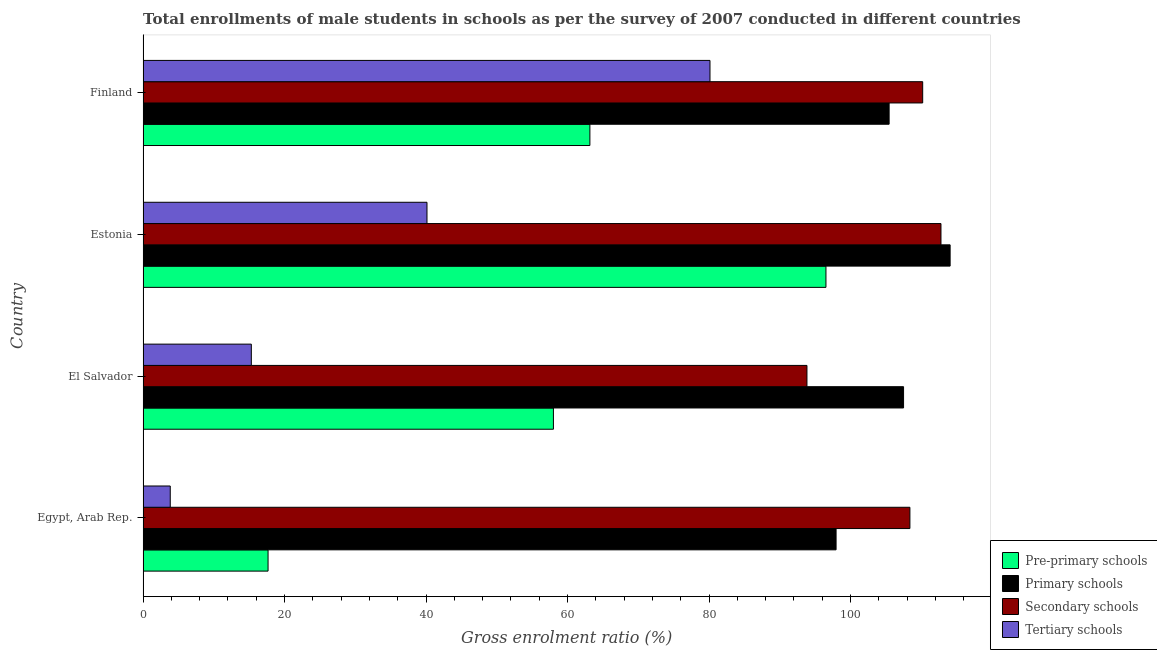Are the number of bars per tick equal to the number of legend labels?
Provide a succinct answer. Yes. How many bars are there on the 3rd tick from the top?
Give a very brief answer. 4. What is the label of the 1st group of bars from the top?
Give a very brief answer. Finland. In how many cases, is the number of bars for a given country not equal to the number of legend labels?
Keep it short and to the point. 0. What is the gross enrolment ratio(male) in pre-primary schools in Egypt, Arab Rep.?
Offer a terse response. 17.67. Across all countries, what is the maximum gross enrolment ratio(male) in pre-primary schools?
Offer a very short reply. 96.53. Across all countries, what is the minimum gross enrolment ratio(male) in pre-primary schools?
Your answer should be very brief. 17.67. In which country was the gross enrolment ratio(male) in primary schools minimum?
Offer a very short reply. Egypt, Arab Rep. What is the total gross enrolment ratio(male) in tertiary schools in the graph?
Offer a terse response. 139.42. What is the difference between the gross enrolment ratio(male) in pre-primary schools in Estonia and that in Finland?
Offer a very short reply. 33.37. What is the difference between the gross enrolment ratio(male) in tertiary schools in Egypt, Arab Rep. and the gross enrolment ratio(male) in secondary schools in El Salvador?
Give a very brief answer. -90. What is the average gross enrolment ratio(male) in secondary schools per country?
Keep it short and to the point. 106.31. What is the difference between the gross enrolment ratio(male) in pre-primary schools and gross enrolment ratio(male) in primary schools in Estonia?
Offer a very short reply. -17.55. In how many countries, is the gross enrolment ratio(male) in tertiary schools greater than 44 %?
Offer a terse response. 1. What is the ratio of the gross enrolment ratio(male) in tertiary schools in El Salvador to that in Finland?
Provide a short and direct response. 0.19. Is the difference between the gross enrolment ratio(male) in tertiary schools in Egypt, Arab Rep. and El Salvador greater than the difference between the gross enrolment ratio(male) in primary schools in Egypt, Arab Rep. and El Salvador?
Your answer should be very brief. No. What is the difference between the highest and the second highest gross enrolment ratio(male) in tertiary schools?
Your response must be concise. 40.01. What is the difference between the highest and the lowest gross enrolment ratio(male) in primary schools?
Give a very brief answer. 16.12. Is it the case that in every country, the sum of the gross enrolment ratio(male) in pre-primary schools and gross enrolment ratio(male) in primary schools is greater than the sum of gross enrolment ratio(male) in tertiary schools and gross enrolment ratio(male) in secondary schools?
Your answer should be compact. No. What does the 1st bar from the top in Estonia represents?
Your answer should be compact. Tertiary schools. What does the 3rd bar from the bottom in Finland represents?
Your response must be concise. Secondary schools. How many bars are there?
Provide a succinct answer. 16. Are all the bars in the graph horizontal?
Make the answer very short. Yes. How many countries are there in the graph?
Keep it short and to the point. 4. How many legend labels are there?
Keep it short and to the point. 4. How are the legend labels stacked?
Give a very brief answer. Vertical. What is the title of the graph?
Give a very brief answer. Total enrollments of male students in schools as per the survey of 2007 conducted in different countries. What is the label or title of the X-axis?
Provide a succinct answer. Gross enrolment ratio (%). What is the label or title of the Y-axis?
Your answer should be compact. Country. What is the Gross enrolment ratio (%) in Pre-primary schools in Egypt, Arab Rep.?
Provide a succinct answer. 17.67. What is the Gross enrolment ratio (%) of Primary schools in Egypt, Arab Rep.?
Offer a very short reply. 97.97. What is the Gross enrolment ratio (%) of Secondary schools in Egypt, Arab Rep.?
Ensure brevity in your answer.  108.4. What is the Gross enrolment ratio (%) of Tertiary schools in Egypt, Arab Rep.?
Ensure brevity in your answer.  3.84. What is the Gross enrolment ratio (%) of Pre-primary schools in El Salvador?
Your response must be concise. 58.01. What is the Gross enrolment ratio (%) of Primary schools in El Salvador?
Your answer should be compact. 107.5. What is the Gross enrolment ratio (%) of Secondary schools in El Salvador?
Offer a terse response. 93.85. What is the Gross enrolment ratio (%) of Tertiary schools in El Salvador?
Your answer should be very brief. 15.31. What is the Gross enrolment ratio (%) in Pre-primary schools in Estonia?
Provide a succinct answer. 96.53. What is the Gross enrolment ratio (%) of Primary schools in Estonia?
Your answer should be compact. 114.09. What is the Gross enrolment ratio (%) of Secondary schools in Estonia?
Offer a terse response. 112.79. What is the Gross enrolment ratio (%) in Tertiary schools in Estonia?
Offer a very short reply. 40.13. What is the Gross enrolment ratio (%) of Pre-primary schools in Finland?
Provide a succinct answer. 63.16. What is the Gross enrolment ratio (%) of Primary schools in Finland?
Give a very brief answer. 105.46. What is the Gross enrolment ratio (%) in Secondary schools in Finland?
Provide a succinct answer. 110.21. What is the Gross enrolment ratio (%) of Tertiary schools in Finland?
Provide a short and direct response. 80.14. Across all countries, what is the maximum Gross enrolment ratio (%) of Pre-primary schools?
Your response must be concise. 96.53. Across all countries, what is the maximum Gross enrolment ratio (%) of Primary schools?
Your answer should be compact. 114.09. Across all countries, what is the maximum Gross enrolment ratio (%) in Secondary schools?
Make the answer very short. 112.79. Across all countries, what is the maximum Gross enrolment ratio (%) of Tertiary schools?
Provide a succinct answer. 80.14. Across all countries, what is the minimum Gross enrolment ratio (%) in Pre-primary schools?
Offer a very short reply. 17.67. Across all countries, what is the minimum Gross enrolment ratio (%) in Primary schools?
Keep it short and to the point. 97.97. Across all countries, what is the minimum Gross enrolment ratio (%) of Secondary schools?
Offer a very short reply. 93.85. Across all countries, what is the minimum Gross enrolment ratio (%) of Tertiary schools?
Offer a terse response. 3.84. What is the total Gross enrolment ratio (%) in Pre-primary schools in the graph?
Offer a terse response. 235.37. What is the total Gross enrolment ratio (%) in Primary schools in the graph?
Ensure brevity in your answer.  425.02. What is the total Gross enrolment ratio (%) of Secondary schools in the graph?
Offer a very short reply. 425.25. What is the total Gross enrolment ratio (%) in Tertiary schools in the graph?
Give a very brief answer. 139.42. What is the difference between the Gross enrolment ratio (%) in Pre-primary schools in Egypt, Arab Rep. and that in El Salvador?
Provide a short and direct response. -40.34. What is the difference between the Gross enrolment ratio (%) of Primary schools in Egypt, Arab Rep. and that in El Salvador?
Your answer should be compact. -9.54. What is the difference between the Gross enrolment ratio (%) of Secondary schools in Egypt, Arab Rep. and that in El Salvador?
Your answer should be very brief. 14.55. What is the difference between the Gross enrolment ratio (%) in Tertiary schools in Egypt, Arab Rep. and that in El Salvador?
Provide a short and direct response. -11.46. What is the difference between the Gross enrolment ratio (%) of Pre-primary schools in Egypt, Arab Rep. and that in Estonia?
Your response must be concise. -78.86. What is the difference between the Gross enrolment ratio (%) in Primary schools in Egypt, Arab Rep. and that in Estonia?
Offer a terse response. -16.12. What is the difference between the Gross enrolment ratio (%) of Secondary schools in Egypt, Arab Rep. and that in Estonia?
Keep it short and to the point. -4.39. What is the difference between the Gross enrolment ratio (%) of Tertiary schools in Egypt, Arab Rep. and that in Estonia?
Offer a terse response. -36.29. What is the difference between the Gross enrolment ratio (%) of Pre-primary schools in Egypt, Arab Rep. and that in Finland?
Give a very brief answer. -45.49. What is the difference between the Gross enrolment ratio (%) of Primary schools in Egypt, Arab Rep. and that in Finland?
Offer a very short reply. -7.5. What is the difference between the Gross enrolment ratio (%) in Secondary schools in Egypt, Arab Rep. and that in Finland?
Offer a terse response. -1.81. What is the difference between the Gross enrolment ratio (%) in Tertiary schools in Egypt, Arab Rep. and that in Finland?
Give a very brief answer. -76.3. What is the difference between the Gross enrolment ratio (%) in Pre-primary schools in El Salvador and that in Estonia?
Provide a short and direct response. -38.53. What is the difference between the Gross enrolment ratio (%) in Primary schools in El Salvador and that in Estonia?
Keep it short and to the point. -6.58. What is the difference between the Gross enrolment ratio (%) in Secondary schools in El Salvador and that in Estonia?
Your answer should be compact. -18.94. What is the difference between the Gross enrolment ratio (%) in Tertiary schools in El Salvador and that in Estonia?
Ensure brevity in your answer.  -24.83. What is the difference between the Gross enrolment ratio (%) in Pre-primary schools in El Salvador and that in Finland?
Offer a very short reply. -5.15. What is the difference between the Gross enrolment ratio (%) in Primary schools in El Salvador and that in Finland?
Provide a short and direct response. 2.04. What is the difference between the Gross enrolment ratio (%) of Secondary schools in El Salvador and that in Finland?
Your answer should be very brief. -16.36. What is the difference between the Gross enrolment ratio (%) in Tertiary schools in El Salvador and that in Finland?
Offer a terse response. -64.83. What is the difference between the Gross enrolment ratio (%) in Pre-primary schools in Estonia and that in Finland?
Give a very brief answer. 33.37. What is the difference between the Gross enrolment ratio (%) in Primary schools in Estonia and that in Finland?
Keep it short and to the point. 8.62. What is the difference between the Gross enrolment ratio (%) of Secondary schools in Estonia and that in Finland?
Offer a very short reply. 2.58. What is the difference between the Gross enrolment ratio (%) in Tertiary schools in Estonia and that in Finland?
Keep it short and to the point. -40.01. What is the difference between the Gross enrolment ratio (%) in Pre-primary schools in Egypt, Arab Rep. and the Gross enrolment ratio (%) in Primary schools in El Salvador?
Ensure brevity in your answer.  -89.83. What is the difference between the Gross enrolment ratio (%) in Pre-primary schools in Egypt, Arab Rep. and the Gross enrolment ratio (%) in Secondary schools in El Salvador?
Your response must be concise. -76.18. What is the difference between the Gross enrolment ratio (%) of Pre-primary schools in Egypt, Arab Rep. and the Gross enrolment ratio (%) of Tertiary schools in El Salvador?
Your answer should be compact. 2.36. What is the difference between the Gross enrolment ratio (%) in Primary schools in Egypt, Arab Rep. and the Gross enrolment ratio (%) in Secondary schools in El Salvador?
Offer a terse response. 4.12. What is the difference between the Gross enrolment ratio (%) in Primary schools in Egypt, Arab Rep. and the Gross enrolment ratio (%) in Tertiary schools in El Salvador?
Keep it short and to the point. 82.66. What is the difference between the Gross enrolment ratio (%) of Secondary schools in Egypt, Arab Rep. and the Gross enrolment ratio (%) of Tertiary schools in El Salvador?
Ensure brevity in your answer.  93.09. What is the difference between the Gross enrolment ratio (%) of Pre-primary schools in Egypt, Arab Rep. and the Gross enrolment ratio (%) of Primary schools in Estonia?
Your answer should be very brief. -96.42. What is the difference between the Gross enrolment ratio (%) of Pre-primary schools in Egypt, Arab Rep. and the Gross enrolment ratio (%) of Secondary schools in Estonia?
Your response must be concise. -95.12. What is the difference between the Gross enrolment ratio (%) in Pre-primary schools in Egypt, Arab Rep. and the Gross enrolment ratio (%) in Tertiary schools in Estonia?
Provide a short and direct response. -22.46. What is the difference between the Gross enrolment ratio (%) of Primary schools in Egypt, Arab Rep. and the Gross enrolment ratio (%) of Secondary schools in Estonia?
Keep it short and to the point. -14.83. What is the difference between the Gross enrolment ratio (%) of Primary schools in Egypt, Arab Rep. and the Gross enrolment ratio (%) of Tertiary schools in Estonia?
Your answer should be very brief. 57.83. What is the difference between the Gross enrolment ratio (%) in Secondary schools in Egypt, Arab Rep. and the Gross enrolment ratio (%) in Tertiary schools in Estonia?
Offer a very short reply. 68.27. What is the difference between the Gross enrolment ratio (%) in Pre-primary schools in Egypt, Arab Rep. and the Gross enrolment ratio (%) in Primary schools in Finland?
Ensure brevity in your answer.  -87.79. What is the difference between the Gross enrolment ratio (%) in Pre-primary schools in Egypt, Arab Rep. and the Gross enrolment ratio (%) in Secondary schools in Finland?
Your response must be concise. -92.54. What is the difference between the Gross enrolment ratio (%) of Pre-primary schools in Egypt, Arab Rep. and the Gross enrolment ratio (%) of Tertiary schools in Finland?
Provide a succinct answer. -62.47. What is the difference between the Gross enrolment ratio (%) in Primary schools in Egypt, Arab Rep. and the Gross enrolment ratio (%) in Secondary schools in Finland?
Provide a succinct answer. -12.24. What is the difference between the Gross enrolment ratio (%) in Primary schools in Egypt, Arab Rep. and the Gross enrolment ratio (%) in Tertiary schools in Finland?
Offer a terse response. 17.83. What is the difference between the Gross enrolment ratio (%) of Secondary schools in Egypt, Arab Rep. and the Gross enrolment ratio (%) of Tertiary schools in Finland?
Ensure brevity in your answer.  28.26. What is the difference between the Gross enrolment ratio (%) in Pre-primary schools in El Salvador and the Gross enrolment ratio (%) in Primary schools in Estonia?
Keep it short and to the point. -56.08. What is the difference between the Gross enrolment ratio (%) of Pre-primary schools in El Salvador and the Gross enrolment ratio (%) of Secondary schools in Estonia?
Keep it short and to the point. -54.78. What is the difference between the Gross enrolment ratio (%) of Pre-primary schools in El Salvador and the Gross enrolment ratio (%) of Tertiary schools in Estonia?
Make the answer very short. 17.87. What is the difference between the Gross enrolment ratio (%) in Primary schools in El Salvador and the Gross enrolment ratio (%) in Secondary schools in Estonia?
Ensure brevity in your answer.  -5.29. What is the difference between the Gross enrolment ratio (%) in Primary schools in El Salvador and the Gross enrolment ratio (%) in Tertiary schools in Estonia?
Provide a succinct answer. 67.37. What is the difference between the Gross enrolment ratio (%) of Secondary schools in El Salvador and the Gross enrolment ratio (%) of Tertiary schools in Estonia?
Your answer should be compact. 53.71. What is the difference between the Gross enrolment ratio (%) of Pre-primary schools in El Salvador and the Gross enrolment ratio (%) of Primary schools in Finland?
Offer a terse response. -47.46. What is the difference between the Gross enrolment ratio (%) in Pre-primary schools in El Salvador and the Gross enrolment ratio (%) in Secondary schools in Finland?
Make the answer very short. -52.2. What is the difference between the Gross enrolment ratio (%) in Pre-primary schools in El Salvador and the Gross enrolment ratio (%) in Tertiary schools in Finland?
Give a very brief answer. -22.13. What is the difference between the Gross enrolment ratio (%) in Primary schools in El Salvador and the Gross enrolment ratio (%) in Secondary schools in Finland?
Your answer should be compact. -2.71. What is the difference between the Gross enrolment ratio (%) of Primary schools in El Salvador and the Gross enrolment ratio (%) of Tertiary schools in Finland?
Ensure brevity in your answer.  27.36. What is the difference between the Gross enrolment ratio (%) of Secondary schools in El Salvador and the Gross enrolment ratio (%) of Tertiary schools in Finland?
Make the answer very short. 13.71. What is the difference between the Gross enrolment ratio (%) of Pre-primary schools in Estonia and the Gross enrolment ratio (%) of Primary schools in Finland?
Your answer should be very brief. -8.93. What is the difference between the Gross enrolment ratio (%) of Pre-primary schools in Estonia and the Gross enrolment ratio (%) of Secondary schools in Finland?
Your answer should be very brief. -13.67. What is the difference between the Gross enrolment ratio (%) of Pre-primary schools in Estonia and the Gross enrolment ratio (%) of Tertiary schools in Finland?
Ensure brevity in your answer.  16.39. What is the difference between the Gross enrolment ratio (%) of Primary schools in Estonia and the Gross enrolment ratio (%) of Secondary schools in Finland?
Provide a short and direct response. 3.88. What is the difference between the Gross enrolment ratio (%) of Primary schools in Estonia and the Gross enrolment ratio (%) of Tertiary schools in Finland?
Make the answer very short. 33.95. What is the difference between the Gross enrolment ratio (%) in Secondary schools in Estonia and the Gross enrolment ratio (%) in Tertiary schools in Finland?
Your answer should be compact. 32.65. What is the average Gross enrolment ratio (%) in Pre-primary schools per country?
Provide a short and direct response. 58.84. What is the average Gross enrolment ratio (%) of Primary schools per country?
Make the answer very short. 106.25. What is the average Gross enrolment ratio (%) of Secondary schools per country?
Provide a succinct answer. 106.31. What is the average Gross enrolment ratio (%) in Tertiary schools per country?
Offer a very short reply. 34.86. What is the difference between the Gross enrolment ratio (%) of Pre-primary schools and Gross enrolment ratio (%) of Primary schools in Egypt, Arab Rep.?
Your answer should be compact. -80.3. What is the difference between the Gross enrolment ratio (%) of Pre-primary schools and Gross enrolment ratio (%) of Secondary schools in Egypt, Arab Rep.?
Keep it short and to the point. -90.73. What is the difference between the Gross enrolment ratio (%) of Pre-primary schools and Gross enrolment ratio (%) of Tertiary schools in Egypt, Arab Rep.?
Your response must be concise. 13.83. What is the difference between the Gross enrolment ratio (%) of Primary schools and Gross enrolment ratio (%) of Secondary schools in Egypt, Arab Rep.?
Your answer should be very brief. -10.43. What is the difference between the Gross enrolment ratio (%) in Primary schools and Gross enrolment ratio (%) in Tertiary schools in Egypt, Arab Rep.?
Your answer should be compact. 94.12. What is the difference between the Gross enrolment ratio (%) of Secondary schools and Gross enrolment ratio (%) of Tertiary schools in Egypt, Arab Rep.?
Give a very brief answer. 104.56. What is the difference between the Gross enrolment ratio (%) of Pre-primary schools and Gross enrolment ratio (%) of Primary schools in El Salvador?
Ensure brevity in your answer.  -49.5. What is the difference between the Gross enrolment ratio (%) of Pre-primary schools and Gross enrolment ratio (%) of Secondary schools in El Salvador?
Provide a succinct answer. -35.84. What is the difference between the Gross enrolment ratio (%) of Pre-primary schools and Gross enrolment ratio (%) of Tertiary schools in El Salvador?
Your response must be concise. 42.7. What is the difference between the Gross enrolment ratio (%) in Primary schools and Gross enrolment ratio (%) in Secondary schools in El Salvador?
Provide a short and direct response. 13.66. What is the difference between the Gross enrolment ratio (%) in Primary schools and Gross enrolment ratio (%) in Tertiary schools in El Salvador?
Offer a very short reply. 92.2. What is the difference between the Gross enrolment ratio (%) of Secondary schools and Gross enrolment ratio (%) of Tertiary schools in El Salvador?
Offer a terse response. 78.54. What is the difference between the Gross enrolment ratio (%) in Pre-primary schools and Gross enrolment ratio (%) in Primary schools in Estonia?
Offer a terse response. -17.55. What is the difference between the Gross enrolment ratio (%) of Pre-primary schools and Gross enrolment ratio (%) of Secondary schools in Estonia?
Provide a short and direct response. -16.26. What is the difference between the Gross enrolment ratio (%) of Pre-primary schools and Gross enrolment ratio (%) of Tertiary schools in Estonia?
Keep it short and to the point. 56.4. What is the difference between the Gross enrolment ratio (%) of Primary schools and Gross enrolment ratio (%) of Secondary schools in Estonia?
Give a very brief answer. 1.29. What is the difference between the Gross enrolment ratio (%) of Primary schools and Gross enrolment ratio (%) of Tertiary schools in Estonia?
Keep it short and to the point. 73.95. What is the difference between the Gross enrolment ratio (%) in Secondary schools and Gross enrolment ratio (%) in Tertiary schools in Estonia?
Offer a very short reply. 72.66. What is the difference between the Gross enrolment ratio (%) in Pre-primary schools and Gross enrolment ratio (%) in Primary schools in Finland?
Offer a terse response. -42.3. What is the difference between the Gross enrolment ratio (%) of Pre-primary schools and Gross enrolment ratio (%) of Secondary schools in Finland?
Your response must be concise. -47.05. What is the difference between the Gross enrolment ratio (%) in Pre-primary schools and Gross enrolment ratio (%) in Tertiary schools in Finland?
Your response must be concise. -16.98. What is the difference between the Gross enrolment ratio (%) in Primary schools and Gross enrolment ratio (%) in Secondary schools in Finland?
Your answer should be compact. -4.75. What is the difference between the Gross enrolment ratio (%) of Primary schools and Gross enrolment ratio (%) of Tertiary schools in Finland?
Provide a short and direct response. 25.32. What is the difference between the Gross enrolment ratio (%) in Secondary schools and Gross enrolment ratio (%) in Tertiary schools in Finland?
Offer a terse response. 30.07. What is the ratio of the Gross enrolment ratio (%) of Pre-primary schools in Egypt, Arab Rep. to that in El Salvador?
Ensure brevity in your answer.  0.3. What is the ratio of the Gross enrolment ratio (%) in Primary schools in Egypt, Arab Rep. to that in El Salvador?
Your answer should be compact. 0.91. What is the ratio of the Gross enrolment ratio (%) in Secondary schools in Egypt, Arab Rep. to that in El Salvador?
Keep it short and to the point. 1.16. What is the ratio of the Gross enrolment ratio (%) of Tertiary schools in Egypt, Arab Rep. to that in El Salvador?
Provide a short and direct response. 0.25. What is the ratio of the Gross enrolment ratio (%) in Pre-primary schools in Egypt, Arab Rep. to that in Estonia?
Offer a terse response. 0.18. What is the ratio of the Gross enrolment ratio (%) in Primary schools in Egypt, Arab Rep. to that in Estonia?
Ensure brevity in your answer.  0.86. What is the ratio of the Gross enrolment ratio (%) in Secondary schools in Egypt, Arab Rep. to that in Estonia?
Your answer should be very brief. 0.96. What is the ratio of the Gross enrolment ratio (%) of Tertiary schools in Egypt, Arab Rep. to that in Estonia?
Your answer should be compact. 0.1. What is the ratio of the Gross enrolment ratio (%) of Pre-primary schools in Egypt, Arab Rep. to that in Finland?
Offer a terse response. 0.28. What is the ratio of the Gross enrolment ratio (%) in Primary schools in Egypt, Arab Rep. to that in Finland?
Keep it short and to the point. 0.93. What is the ratio of the Gross enrolment ratio (%) in Secondary schools in Egypt, Arab Rep. to that in Finland?
Ensure brevity in your answer.  0.98. What is the ratio of the Gross enrolment ratio (%) of Tertiary schools in Egypt, Arab Rep. to that in Finland?
Provide a short and direct response. 0.05. What is the ratio of the Gross enrolment ratio (%) of Pre-primary schools in El Salvador to that in Estonia?
Make the answer very short. 0.6. What is the ratio of the Gross enrolment ratio (%) in Primary schools in El Salvador to that in Estonia?
Give a very brief answer. 0.94. What is the ratio of the Gross enrolment ratio (%) in Secondary schools in El Salvador to that in Estonia?
Your answer should be very brief. 0.83. What is the ratio of the Gross enrolment ratio (%) in Tertiary schools in El Salvador to that in Estonia?
Provide a succinct answer. 0.38. What is the ratio of the Gross enrolment ratio (%) in Pre-primary schools in El Salvador to that in Finland?
Ensure brevity in your answer.  0.92. What is the ratio of the Gross enrolment ratio (%) of Primary schools in El Salvador to that in Finland?
Provide a short and direct response. 1.02. What is the ratio of the Gross enrolment ratio (%) of Secondary schools in El Salvador to that in Finland?
Provide a short and direct response. 0.85. What is the ratio of the Gross enrolment ratio (%) in Tertiary schools in El Salvador to that in Finland?
Offer a very short reply. 0.19. What is the ratio of the Gross enrolment ratio (%) in Pre-primary schools in Estonia to that in Finland?
Make the answer very short. 1.53. What is the ratio of the Gross enrolment ratio (%) in Primary schools in Estonia to that in Finland?
Provide a short and direct response. 1.08. What is the ratio of the Gross enrolment ratio (%) of Secondary schools in Estonia to that in Finland?
Give a very brief answer. 1.02. What is the ratio of the Gross enrolment ratio (%) in Tertiary schools in Estonia to that in Finland?
Your response must be concise. 0.5. What is the difference between the highest and the second highest Gross enrolment ratio (%) in Pre-primary schools?
Offer a very short reply. 33.37. What is the difference between the highest and the second highest Gross enrolment ratio (%) in Primary schools?
Your response must be concise. 6.58. What is the difference between the highest and the second highest Gross enrolment ratio (%) of Secondary schools?
Offer a very short reply. 2.58. What is the difference between the highest and the second highest Gross enrolment ratio (%) of Tertiary schools?
Keep it short and to the point. 40.01. What is the difference between the highest and the lowest Gross enrolment ratio (%) in Pre-primary schools?
Your answer should be compact. 78.86. What is the difference between the highest and the lowest Gross enrolment ratio (%) in Primary schools?
Your answer should be very brief. 16.12. What is the difference between the highest and the lowest Gross enrolment ratio (%) in Secondary schools?
Give a very brief answer. 18.94. What is the difference between the highest and the lowest Gross enrolment ratio (%) of Tertiary schools?
Your answer should be very brief. 76.3. 